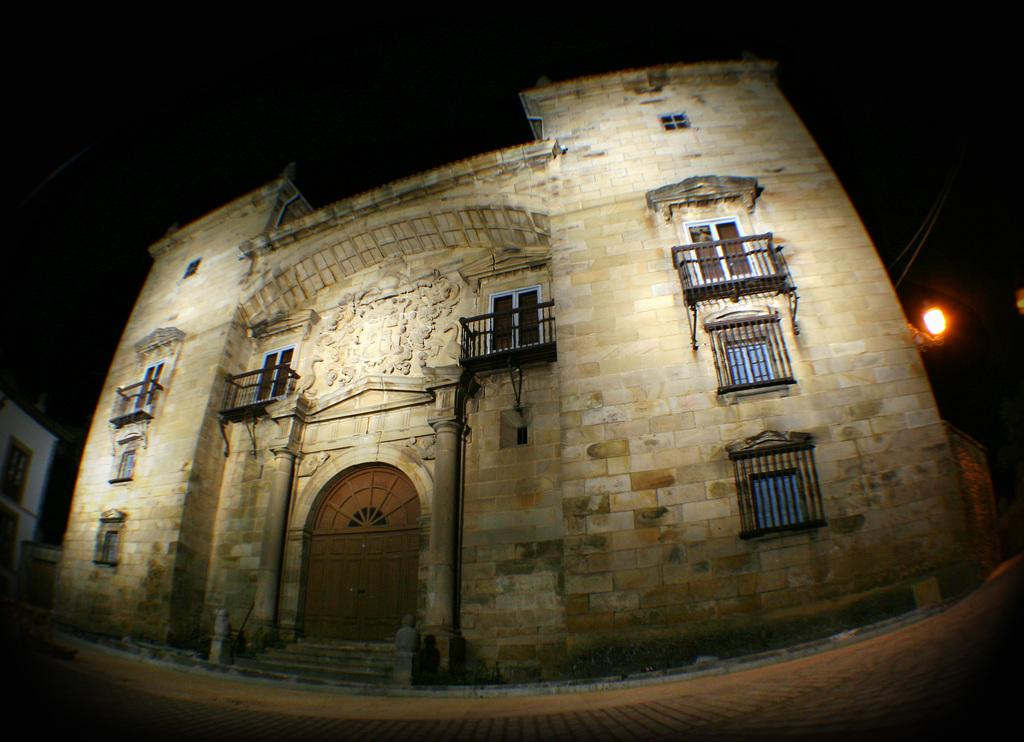What is the main structure visible in the image? There is a building in the image. Can you describe any other structures in the image? There is another building on the left side of the image. What type of illumination is present in the image? There is a light in the image. How would you describe the overall lighting in the image? The background of the image is dark. What type of friction can be seen between the two buildings in the image? There is no friction visible between the buildings in the image, as they are separate structures. 